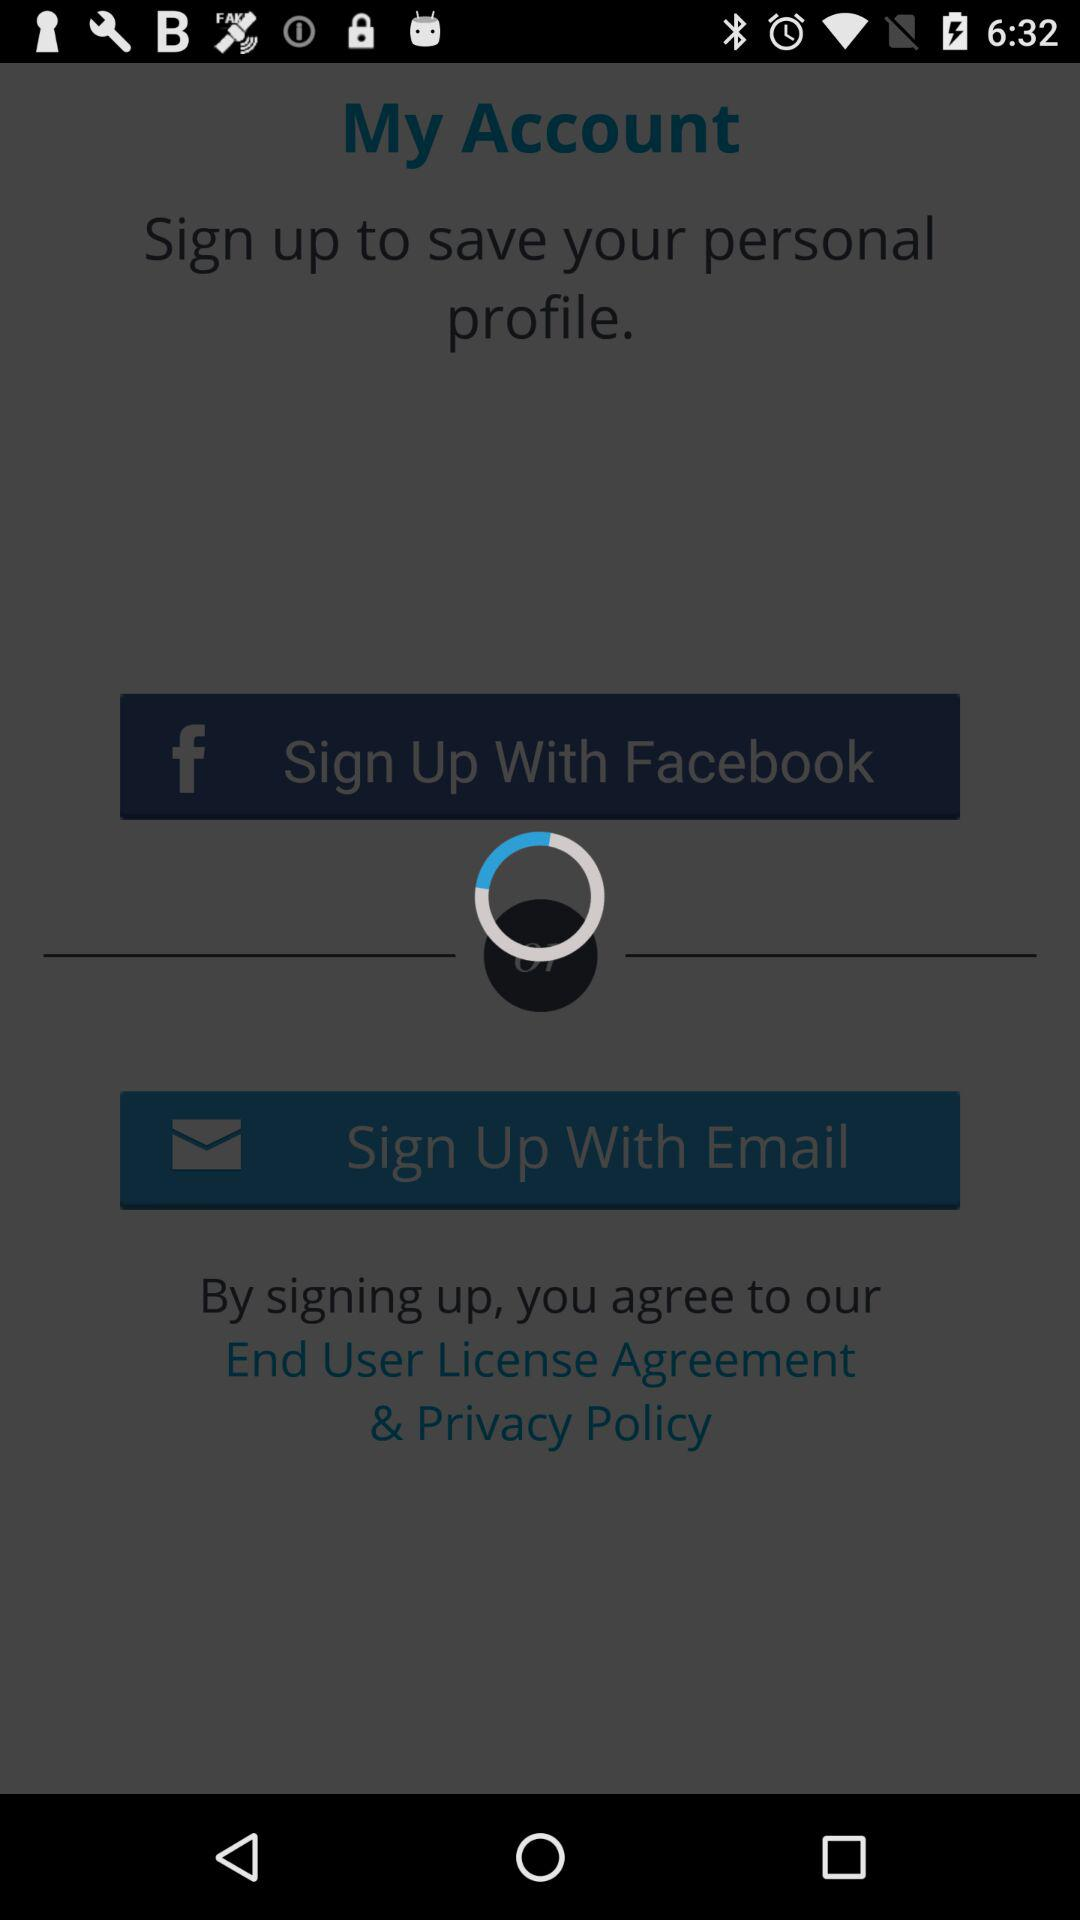What is the user's name?
When the provided information is insufficient, respond with <no answer>. <no answer> 